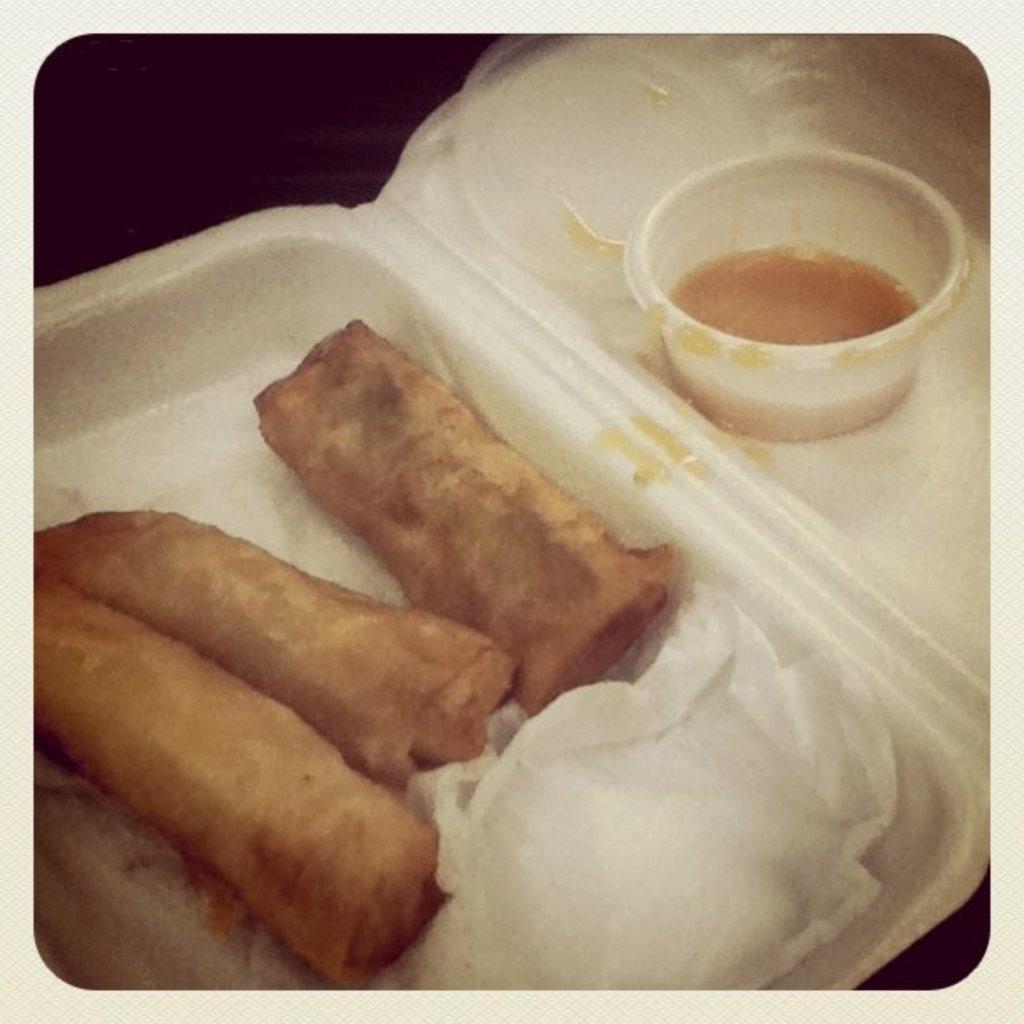Can you describe this image briefly? In this picture we can see a tray which is white in colour and these are the rolls. There are three rolls in a tray. This is a tissue paper. Aside to this tree there is a box and there is some kind of kind of liquid in it and this is a cap of the bottle. 